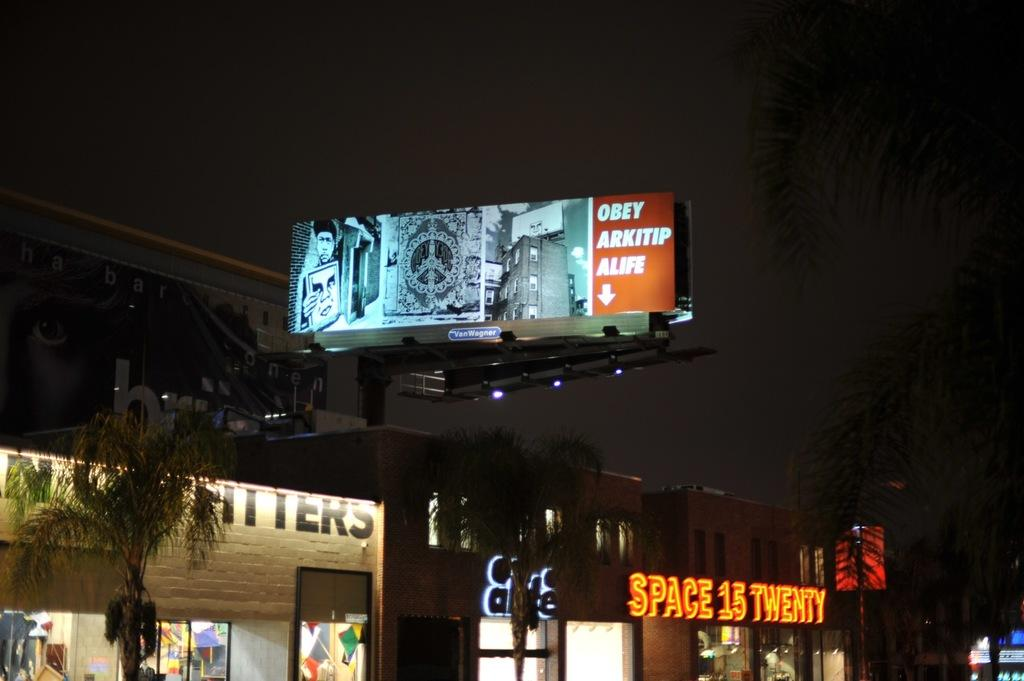<image>
Present a compact description of the photo's key features. One of the stores along the street is Space 15 Twenty. 